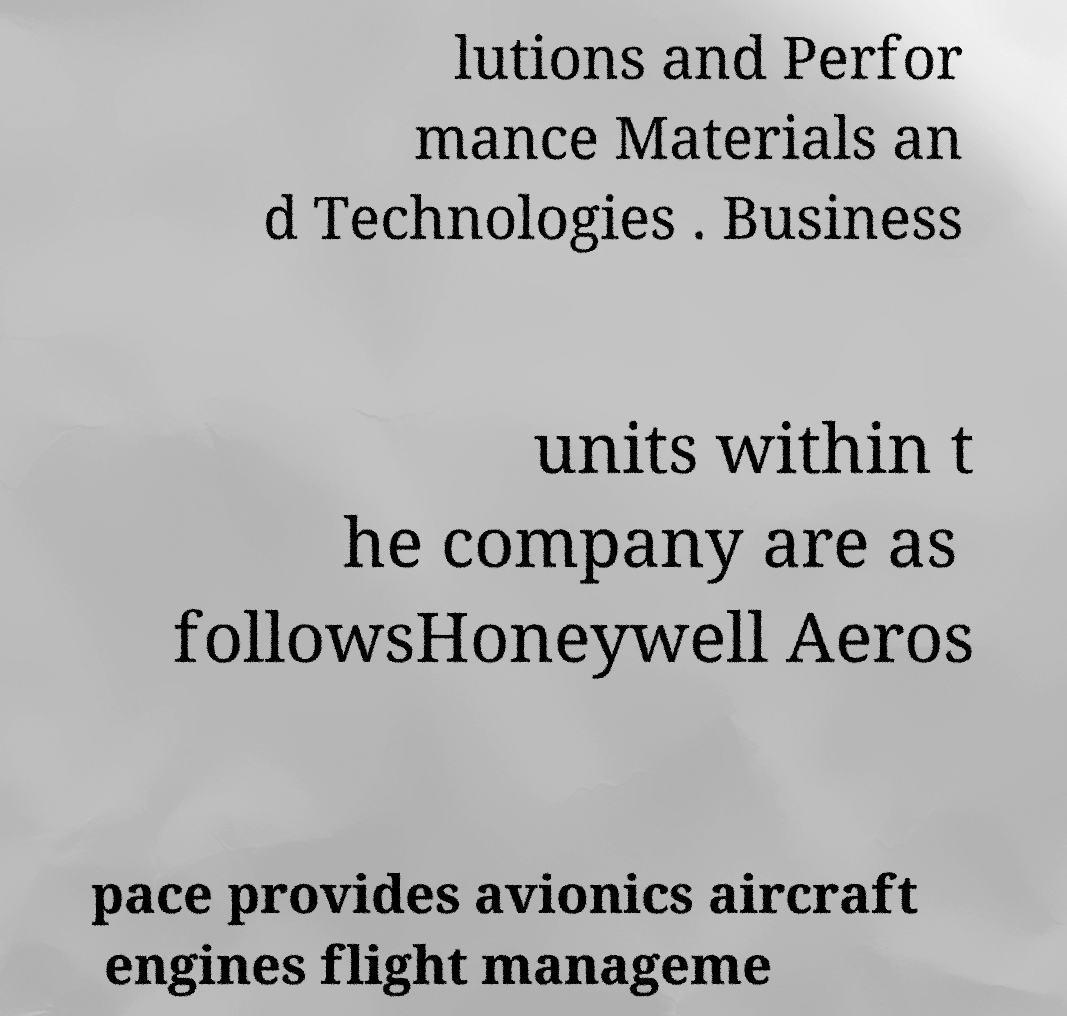Can you accurately transcribe the text from the provided image for me? lutions and Perfor mance Materials an d Technologies . Business units within t he company are as followsHoneywell Aeros pace provides avionics aircraft engines flight manageme 